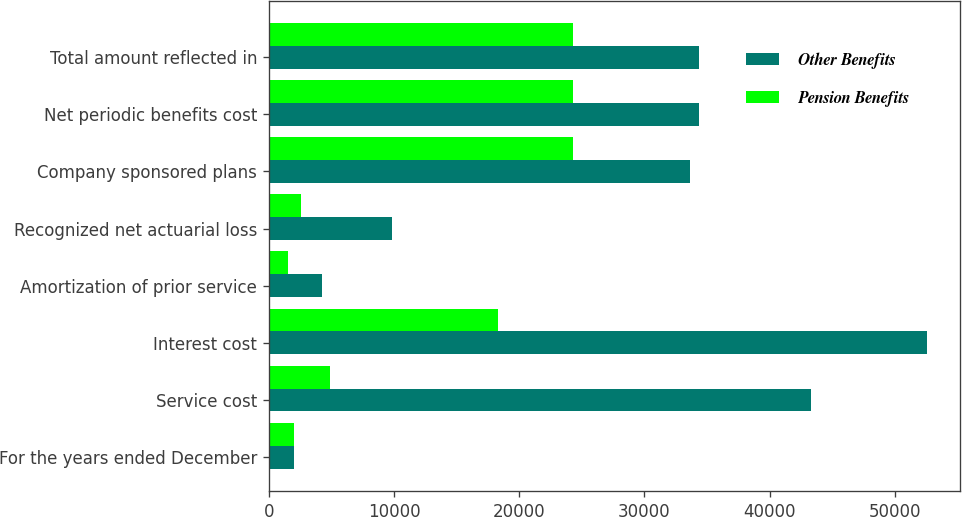Convert chart. <chart><loc_0><loc_0><loc_500><loc_500><stacked_bar_chart><ecel><fcel>For the years ended December<fcel>Service cost<fcel>Interest cost<fcel>Amortization of prior service<fcel>Recognized net actuarial loss<fcel>Company sponsored plans<fcel>Net periodic benefits cost<fcel>Total amount reflected in<nl><fcel>Other Benefits<fcel>2004<fcel>43296<fcel>52551<fcel>4245<fcel>9812<fcel>33605<fcel>34378<fcel>34378<nl><fcel>Pension Benefits<fcel>2004<fcel>4898<fcel>18335<fcel>1507<fcel>2554<fcel>24280<fcel>24280<fcel>24280<nl></chart> 